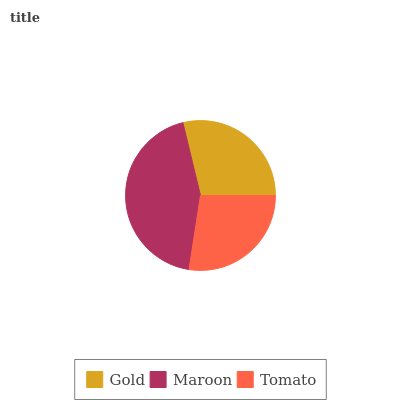Is Tomato the minimum?
Answer yes or no. Yes. Is Maroon the maximum?
Answer yes or no. Yes. Is Maroon the minimum?
Answer yes or no. No. Is Tomato the maximum?
Answer yes or no. No. Is Maroon greater than Tomato?
Answer yes or no. Yes. Is Tomato less than Maroon?
Answer yes or no. Yes. Is Tomato greater than Maroon?
Answer yes or no. No. Is Maroon less than Tomato?
Answer yes or no. No. Is Gold the high median?
Answer yes or no. Yes. Is Gold the low median?
Answer yes or no. Yes. Is Maroon the high median?
Answer yes or no. No. Is Maroon the low median?
Answer yes or no. No. 